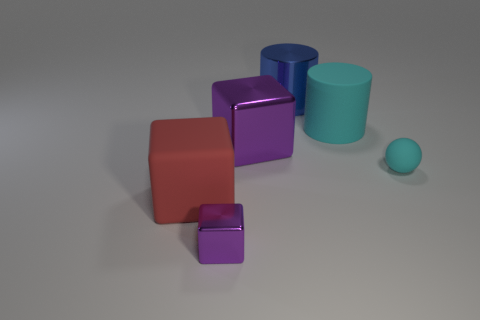Subtract all matte cubes. How many cubes are left? 2 Add 2 big gray spheres. How many objects exist? 8 Subtract all cyan cylinders. How many cylinders are left? 1 Subtract all red balls. How many purple blocks are left? 2 Subtract all purple things. Subtract all blue matte balls. How many objects are left? 4 Add 2 big blue shiny things. How many big blue shiny things are left? 3 Add 5 big cyan objects. How many big cyan objects exist? 6 Subtract 0 green blocks. How many objects are left? 6 Subtract all spheres. How many objects are left? 5 Subtract all cyan cubes. Subtract all red cylinders. How many cubes are left? 3 